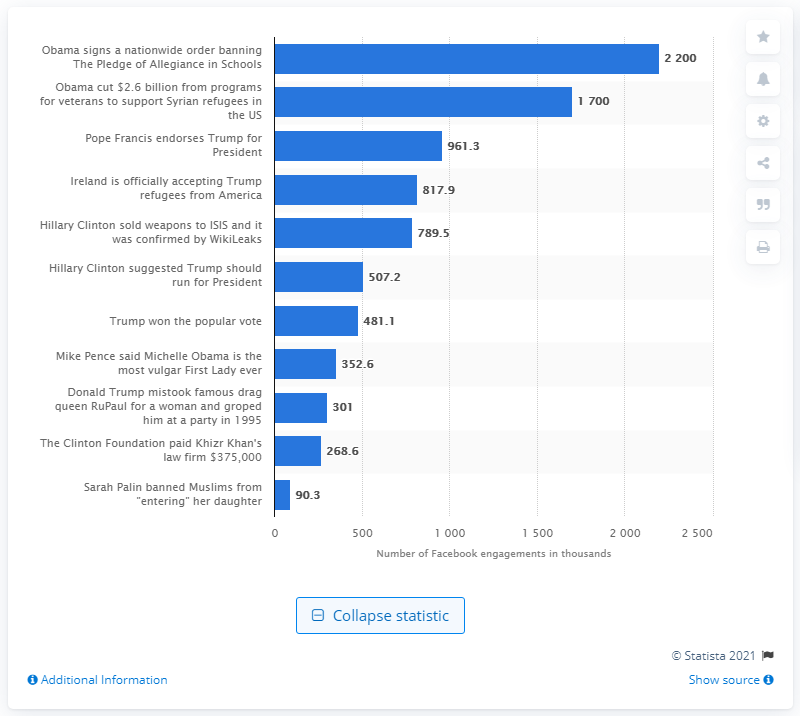How many times was the fake news story shared on Facebook in the three months leading up to the election? The fake news story claiming that 'Obama signs a nationwide order banning The Pledge of Allegiance in Schools' was the most widely circulated on Facebook in the three months preceding the election, reaching approximately 2,200,000 shares, as depicted by the chart. 